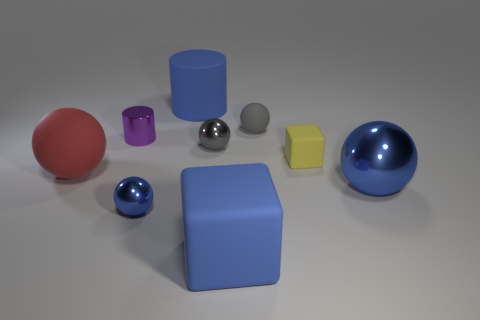Do the tiny sphere that is behind the gray metal ball and the tiny shiny ball behind the large blue ball have the same color?
Offer a terse response. Yes. There is a ball on the right side of the yellow block; are there any gray things that are right of it?
Give a very brief answer. No. There is a large matte object left of the large blue rubber cylinder; is its shape the same as the big thing behind the small rubber sphere?
Your response must be concise. No. Do the cube in front of the large blue metal object and the big blue thing that is behind the big red matte ball have the same material?
Ensure brevity in your answer.  Yes. The blue sphere to the right of the big rubber object behind the small yellow thing is made of what material?
Ensure brevity in your answer.  Metal. The small matte thing that is in front of the matte ball right of the block in front of the large blue metallic object is what shape?
Offer a very short reply. Cube. What is the material of the big red thing that is the same shape as the large blue shiny thing?
Your answer should be very brief. Rubber. What number of blue metallic objects are there?
Your answer should be very brief. 2. The blue rubber object in front of the purple thing has what shape?
Offer a very short reply. Cube. What is the color of the shiny object on the right side of the tiny matte block to the right of the blue object that is behind the tiny rubber block?
Ensure brevity in your answer.  Blue. 